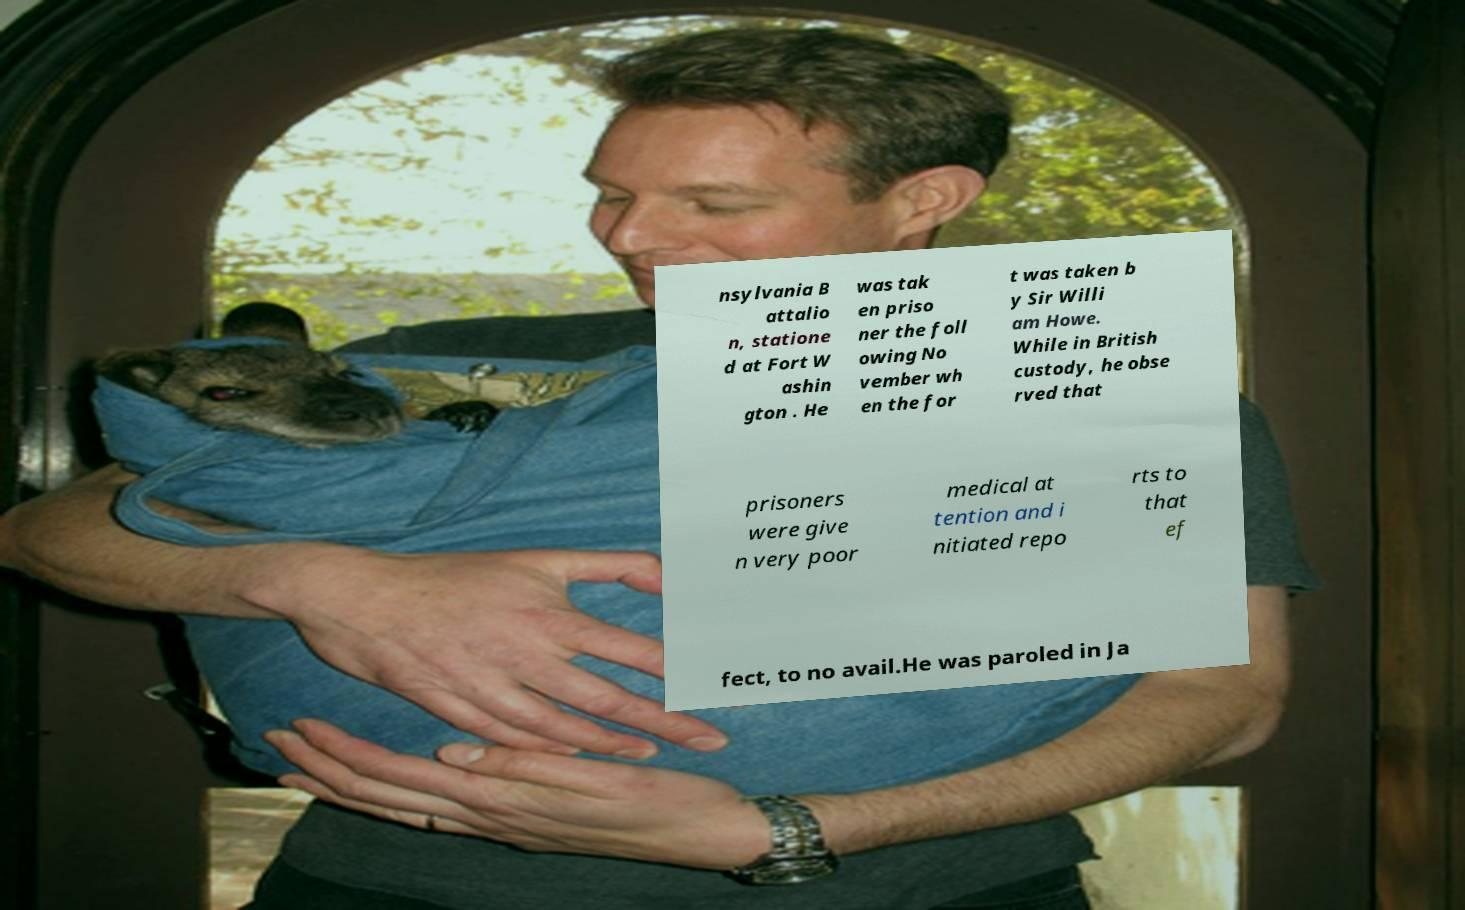For documentation purposes, I need the text within this image transcribed. Could you provide that? nsylvania B attalio n, statione d at Fort W ashin gton . He was tak en priso ner the foll owing No vember wh en the for t was taken b y Sir Willi am Howe. While in British custody, he obse rved that prisoners were give n very poor medical at tention and i nitiated repo rts to that ef fect, to no avail.He was paroled in Ja 